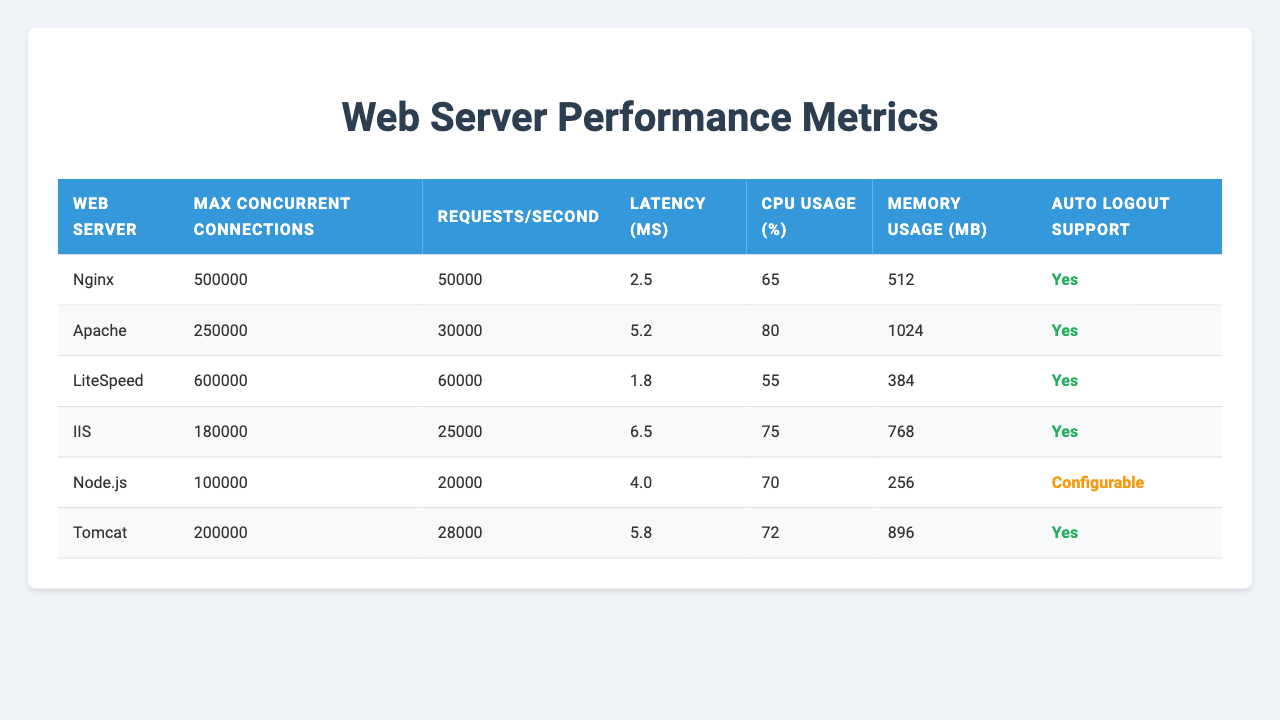What is the maximum concurrent connections supported by Nginx? In the table, under the "Max Concurrent Connections" column, the entry for Nginx shows a maximum of 500,000 connections.
Answer: 500,000 Which web server has the lowest latency and what is its value? By examining the "Latency (ms)" column, LiteSpeed has the lowest latency of 1.8 ms among the listed web servers.
Answer: 1.8 ms What is the total CPU usage percentage of Apache and Tomcat combined? Adding the CPU usage percentages from the "CPU Usage (%)" column for Apache (80%) and Tomcat (72%) gives a total of 152%.
Answer: 152% Does Node.js support auto logout functionality? Checking the "Auto Logout Support" column for Node.js indicates it has "Configurable" support, suggesting it can potentially be set up for auto logout.
Answer: Yes Which web server uses the least amount of memory? From the "Memory Usage (MB)" column, the values show that Node.js uses the least memory at 256 MB.
Answer: 256 MB How much more latency does IIS have compared to Nginx? By looking at the "Latency (ms)" values, we see IIS has a latency of 6.5 ms while Nginx has 2.5 ms. The difference is 6.5 - 2.5 = 4 ms.
Answer: 4 ms Which server has the highest requests per second and what is the value? In the "Requests/Second" column, LiteSpeed has the highest value with 60,000 requests per second.
Answer: 60,000 Is there a web server with a maximum concurrent connection threshold above 550,000? Looking at the "Max Concurrent Connections" column, no web server exceeds 550,000 connections; LiteSpeed is the highest at 600,000, which is equal but not above.
Answer: No What is the average memory usage across all web servers listed? Summing the memory usage: (512 + 1024 + 384 + 768 + 256 + 896) = 3840 MB. There are 6 servers, so the average is 3840 / 6 = 640 MB.
Answer: 640 MB Which server has the highest CPU usage and what is the percentage? The "CPU Usage (%)" column shows that Apache has the highest CPU usage at 80%.
Answer: 80% 